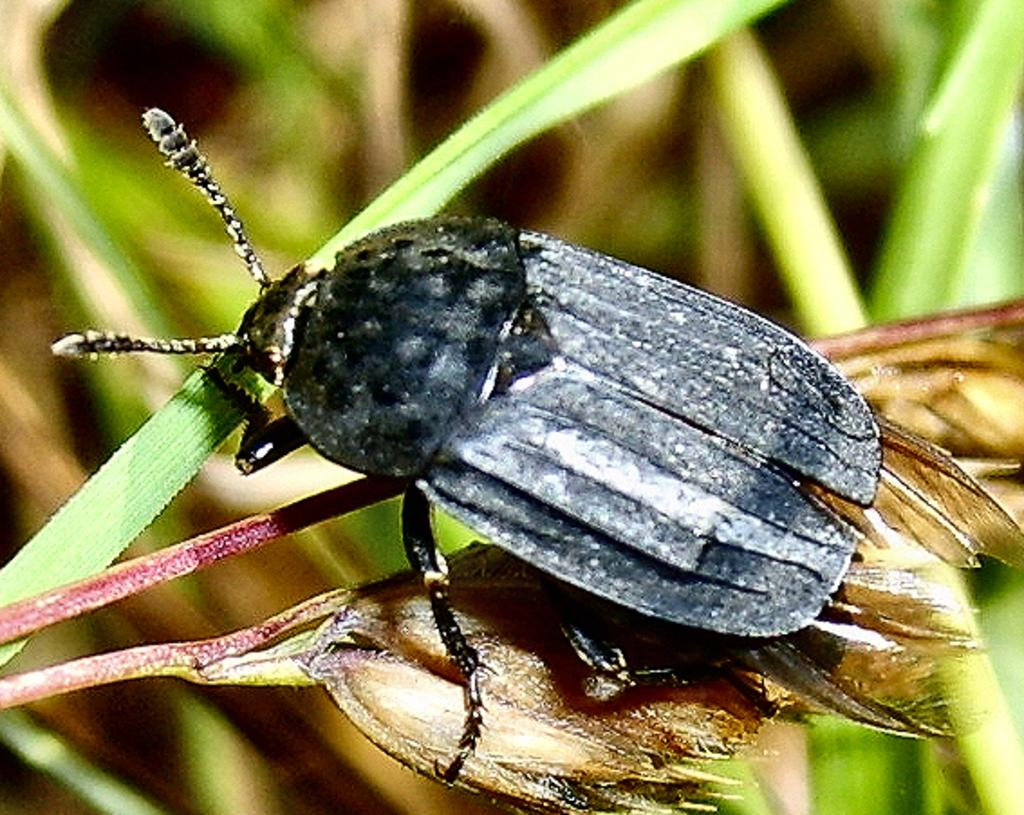What type of creature is in the image? There is an insect in the image. Where is the insect located? The insect is on a plant. Can you describe the background of the image? The background of the image is blurred. What language is the insect speaking in the image? Insects do not speak any language, so this question cannot be answered. 